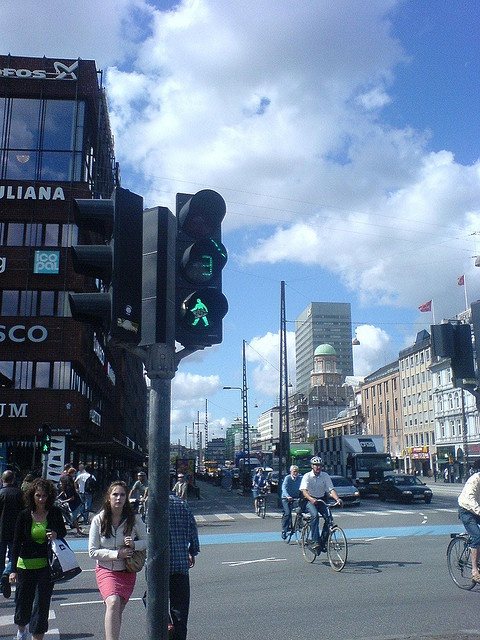Describe the objects in this image and their specific colors. I can see traffic light in lavender, navy, black, blue, and gray tones, people in lavender, black, gray, and darkgreen tones, people in lavender, gray, black, and darkgray tones, people in lavender, black, navy, blue, and gray tones, and truck in lavender, black, navy, and blue tones in this image. 